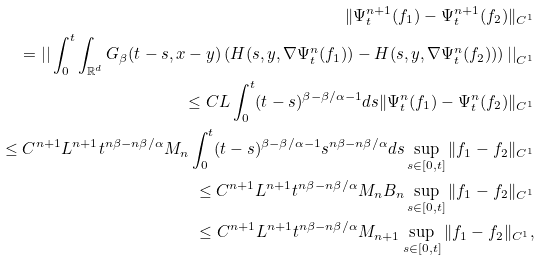<formula> <loc_0><loc_0><loc_500><loc_500>\| \Psi ^ { n + 1 } _ { t } ( f _ { 1 } ) - \Psi ^ { n + 1 } _ { t } ( f _ { 2 } ) \| _ { C ^ { 1 } } \\ = \left | \right | \int _ { 0 } ^ { t } \int _ { \mathbb { R } ^ { d } } G _ { \beta } ( t - s , x - y ) \left ( H ( s , y , \nabla \Psi ^ { n } _ { t } ( f _ { 1 } ) ) - H ( s , y , \nabla \Psi ^ { n } _ { t } ( f _ { 2 } ) ) \right ) \left | \right | _ { C ^ { 1 } } \\ \leq C L \int _ { 0 } ^ { t } ( t - s ) ^ { \beta - \beta / \alpha - 1 } d s \| \Psi ^ { n } _ { t } ( f _ { 1 } ) - \Psi ^ { n } _ { t } ( f _ { 2 } ) \| _ { C ^ { 1 } } \\ \leq C ^ { n + 1 } L ^ { n + 1 } t ^ { n \beta - n \beta / \alpha } M _ { n } \int _ { 0 } ^ { t } ( t - s ) ^ { \beta - \beta / \alpha - 1 } s ^ { n \beta - n \beta / \alpha } d s \sup _ { s \in [ 0 , t ] } \| f _ { 1 } - f _ { 2 } \| _ { C ^ { 1 } } \\ \leq C ^ { n + 1 } L ^ { n + 1 } t ^ { n \beta - n \beta / \alpha } M _ { n } B _ { n } \sup _ { s \in [ 0 , t ] } \| f _ { 1 } - f _ { 2 } \| _ { C ^ { 1 } } \\ \leq C ^ { n + 1 } L ^ { n + 1 } t ^ { n \beta - n \beta / \alpha } M _ { n + 1 } \sup _ { s \in [ 0 , t ] } \| f _ { 1 } - f _ { 2 } \| _ { C ^ { 1 } } ,</formula> 